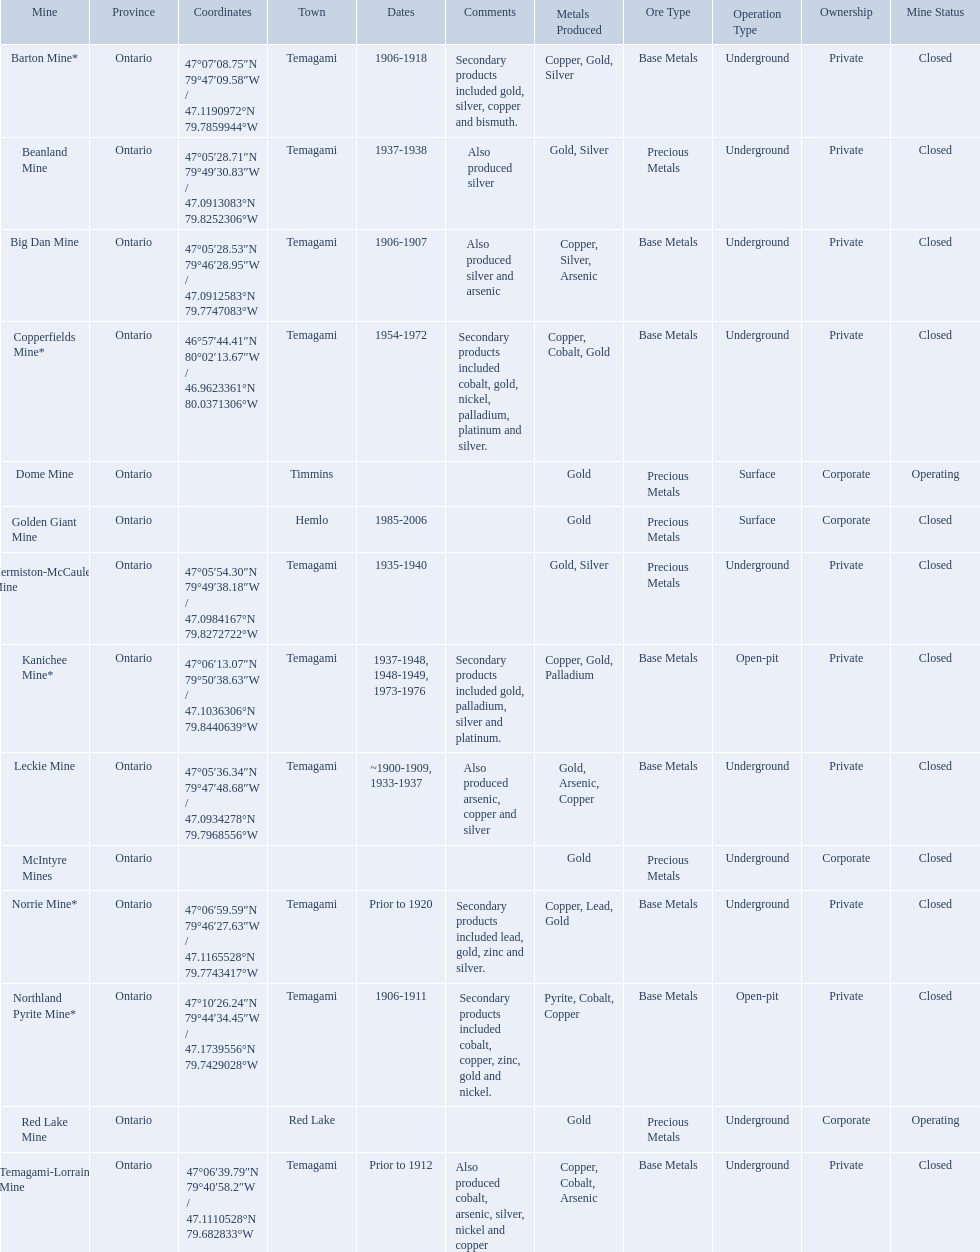What are all the mines with dates listed? Barton Mine*, Beanland Mine, Big Dan Mine, Copperfields Mine*, Golden Giant Mine, Hermiston-McCauley Mine, Kanichee Mine*, Leckie Mine, Norrie Mine*, Northland Pyrite Mine*, Temagami-Lorrain Mine. Which of those dates include the year that the mine was closed? 1906-1918, 1937-1938, 1906-1907, 1954-1972, 1985-2006, 1935-1940, 1937-1948, 1948-1949, 1973-1976, ~1900-1909, 1933-1937, 1906-1911. Which of those mines were opened the longest? Golden Giant Mine. What years was the golden giant mine open for? 1985-2006. What years was the beanland mine open? 1937-1938. Which of these two mines was open longer? Golden Giant Mine. 